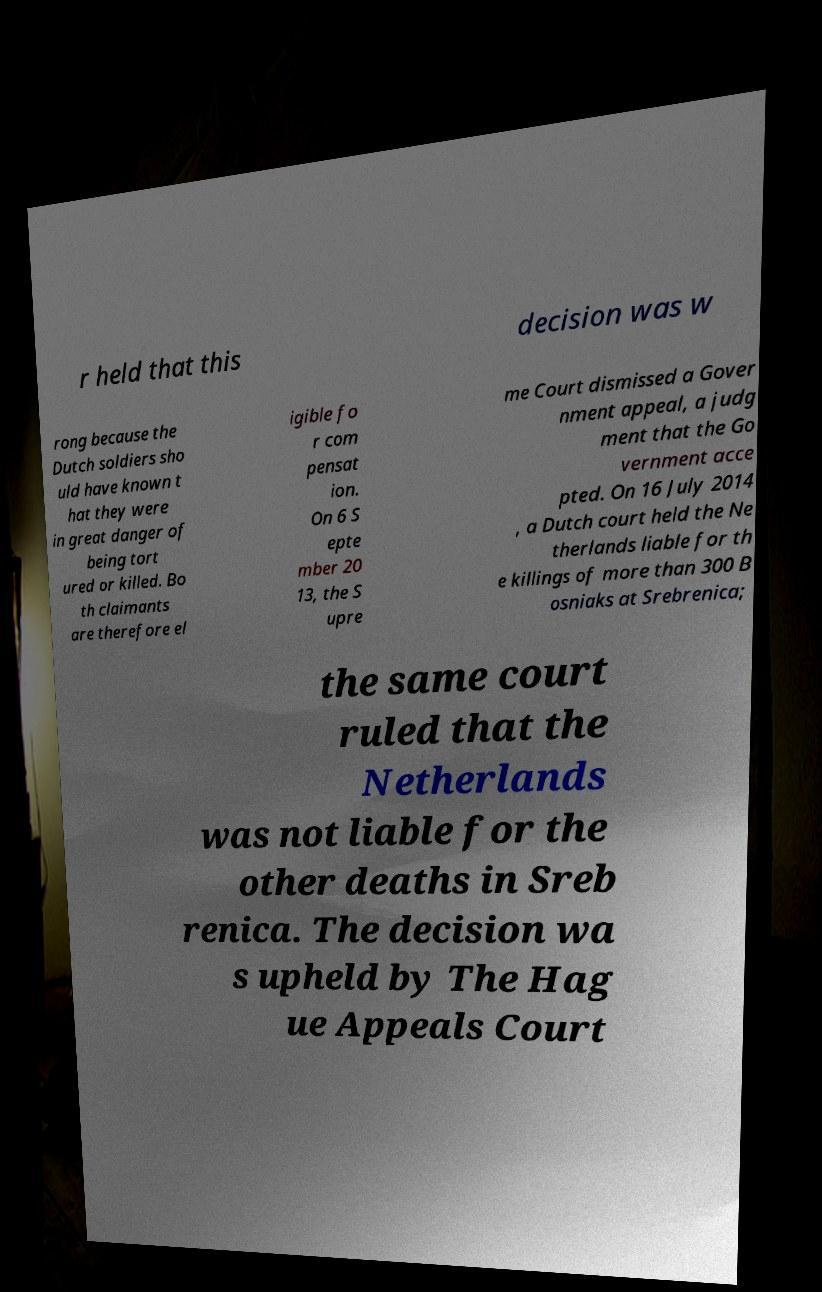I need the written content from this picture converted into text. Can you do that? r held that this decision was w rong because the Dutch soldiers sho uld have known t hat they were in great danger of being tort ured or killed. Bo th claimants are therefore el igible fo r com pensat ion. On 6 S epte mber 20 13, the S upre me Court dismissed a Gover nment appeal, a judg ment that the Go vernment acce pted. On 16 July 2014 , a Dutch court held the Ne therlands liable for th e killings of more than 300 B osniaks at Srebrenica; the same court ruled that the Netherlands was not liable for the other deaths in Sreb renica. The decision wa s upheld by The Hag ue Appeals Court 